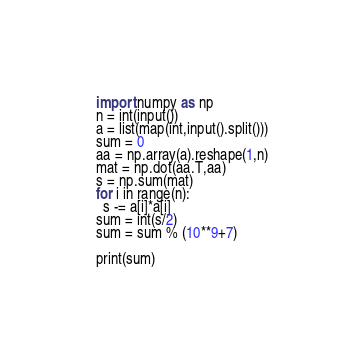<code> <loc_0><loc_0><loc_500><loc_500><_Python_>import numpy as np
n = int(input())
a = list(map(int,input().split()))
sum = 0
aa = np.array(a).reshape(1,n)
mat = np.dot(aa.T,aa)
s = np.sum(mat)
for i in range(n):
  s -= a[i]*a[i]
sum = int(s/2)
sum = sum % (10**9+7)

print(sum)</code> 